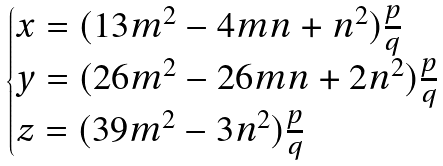Convert formula to latex. <formula><loc_0><loc_0><loc_500><loc_500>\begin{cases} x = ( 1 3 m ^ { 2 } - 4 m n + n ^ { 2 } ) \frac { p } { q } \\ y = ( 2 6 m ^ { 2 } - 2 6 m n + 2 n ^ { 2 } ) \frac { p } { q } \\ z = ( 3 9 m ^ { 2 } - 3 n ^ { 2 } ) \frac { p } { q } \end{cases}</formula> 